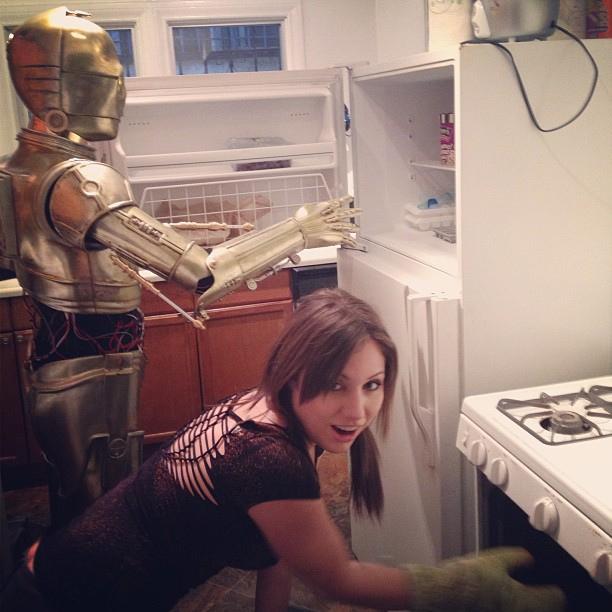What is the little girl looking at?
Short answer required. Camera. Is the oven hot?
Keep it brief. Yes. The fridge is full of what?
Be succinct. Food. Who is searching in the freezer?
Write a very short answer. Robot. Is this a gas stove?
Write a very short answer. Yes. 